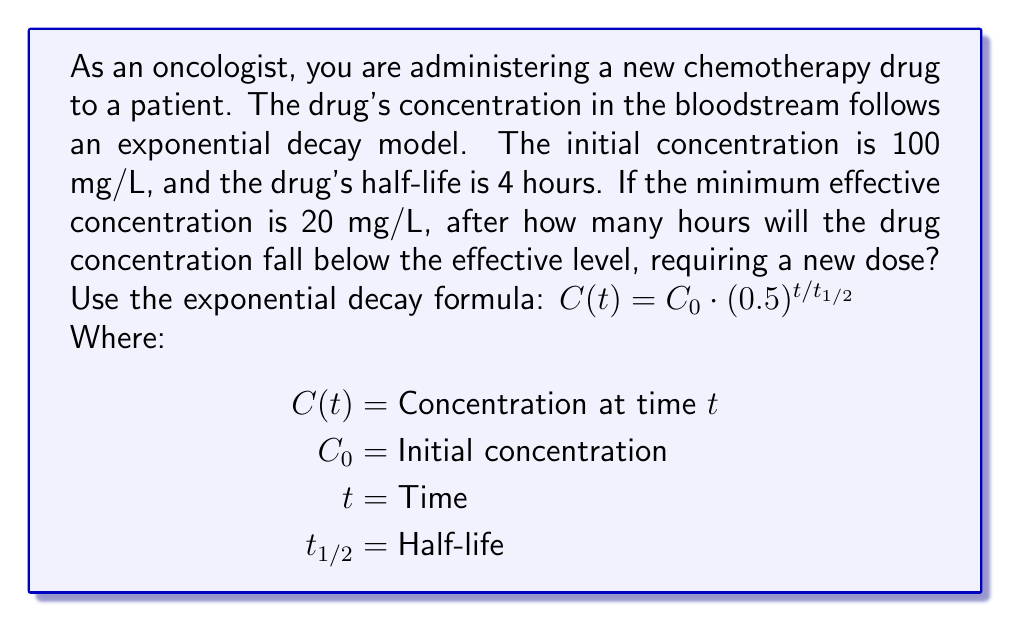Give your solution to this math problem. Let's approach this step-by-step:

1) We're given:
   $C_0 = 100$ mg/L (initial concentration)
   $t_{1/2} = 4$ hours (half-life)
   $C(t) = 20$ mg/L (minimum effective concentration)

2) We need to find $t$ when $C(t) = 20$ mg/L.

3) Let's use the exponential decay formula:

   $C(t) = C_0 \cdot (0.5)^{t/t_{1/2}}$

4) Substituting our known values:

   $20 = 100 \cdot (0.5)^{t/4}$

5) Divide both sides by 100:

   $0.2 = (0.5)^{t/4}$

6) Take the logarithm (base 2) of both sides:

   $\log_2(0.2) = \log_2((0.5)^{t/4})$

7) Using the logarithm property $\log_a(x^n) = n\log_a(x)$:

   $\log_2(0.2) = \frac{t}{4} \log_2(0.5)$

8) Simplify $\log_2(0.5) = -1$:

   $\log_2(0.2) = -\frac{t}{4}$

9) Multiply both sides by -4:

   $-4\log_2(0.2) = t$

10) Calculate:
    $t \approx 13.288$ hours

11) Since we can't administer a partial hour in practice, we round down to ensure we're still above the minimum effective concentration.
Answer: The drug concentration will fall below the effective level after 13 hours, requiring a new dose at that time. 